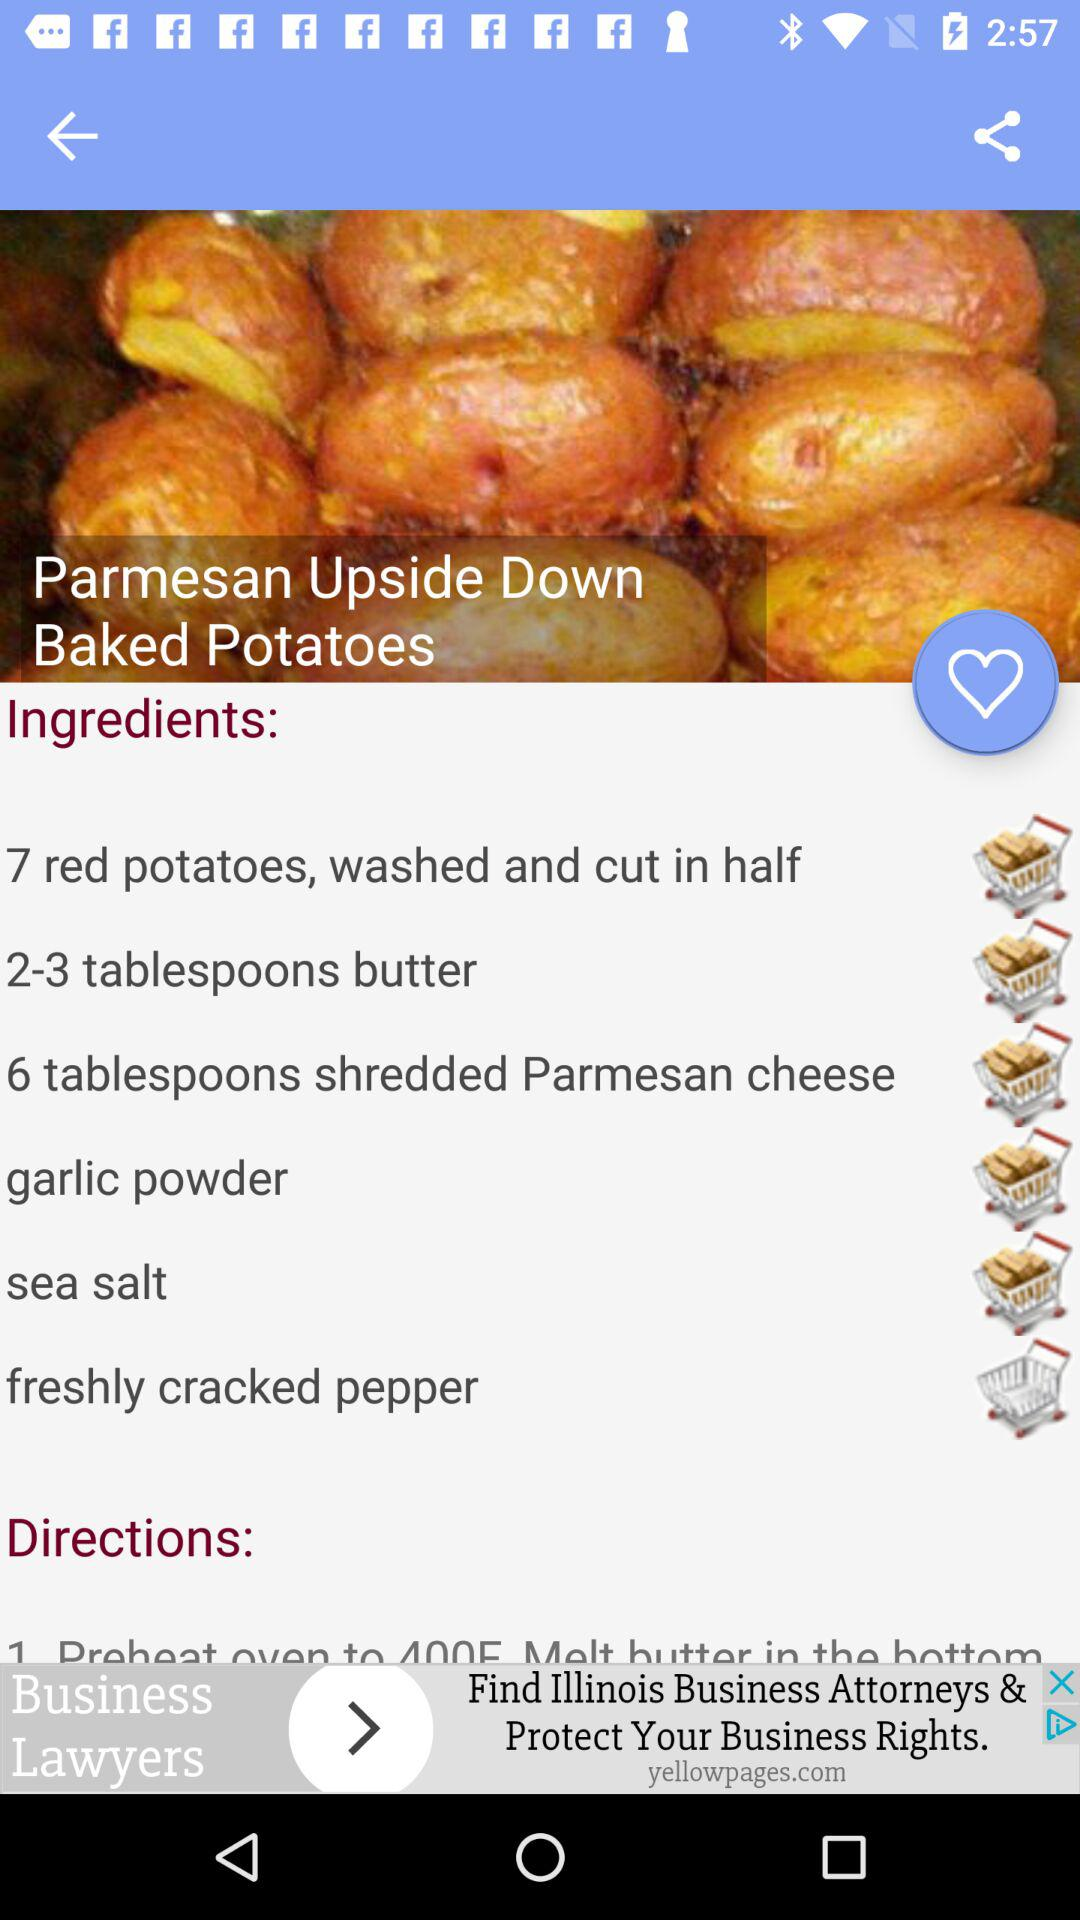What are the different ingredients in the "Parmesan Upside Down Baked Potatoes"? The different ingredients are "7 red potatoes, washed and cut in half", "2-3 tablespoons butter", "6 tablespoons shredded Parmesan cheese", "garlic powder", "sea salt", and "freshly cracked pepper". 